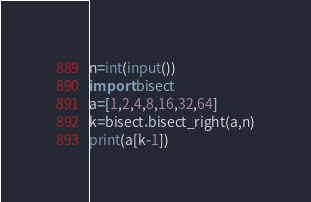<code> <loc_0><loc_0><loc_500><loc_500><_Python_>n=int(input())
import bisect
a=[1,2,4,8,16,32,64]
k=bisect.bisect_right(a,n)
print(a[k-1])</code> 